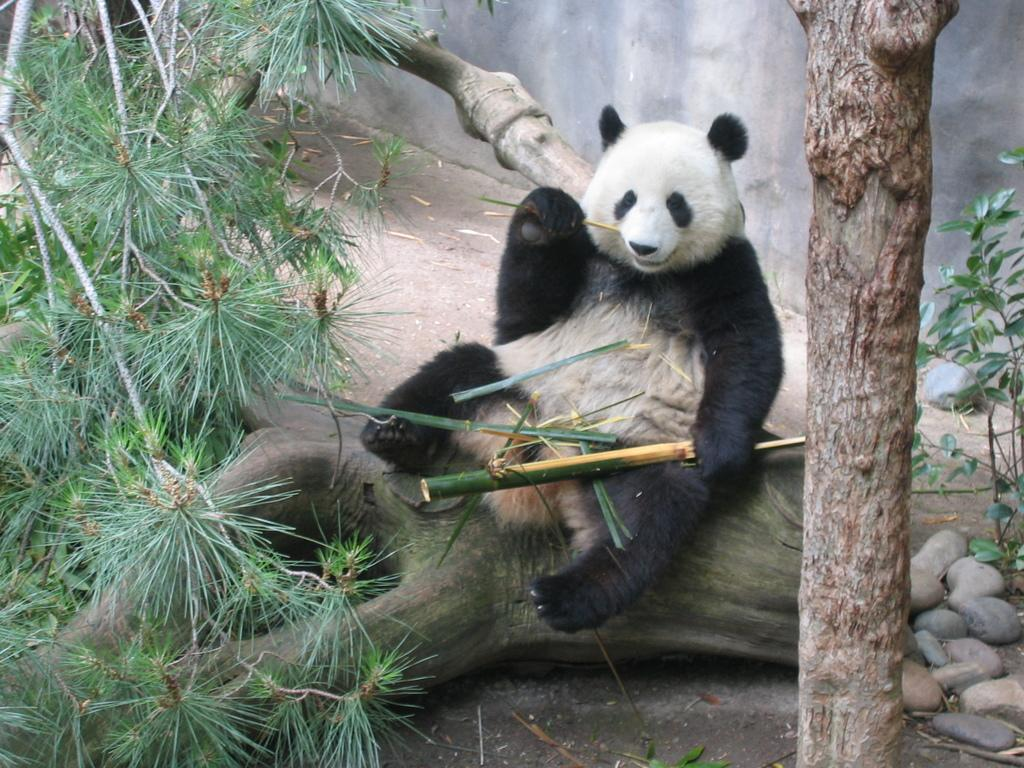What animal is in the image? There is a panda in the image. What is the panda sitting on? The panda is sitting on the bark of a tree. What can be seen on the left side of the image? There are trees on the left side of the image. What is present on the right side of the image? There are stones on the right side of the image. What type of field can be seen in the image? There is no field present in the image; it features a panda sitting on a tree and stones on the right side. What is the panda using to brush its teeth in the image? Pandas do not brush their teeth, and there is no toothbrush or any other object related to teeth in the image. 